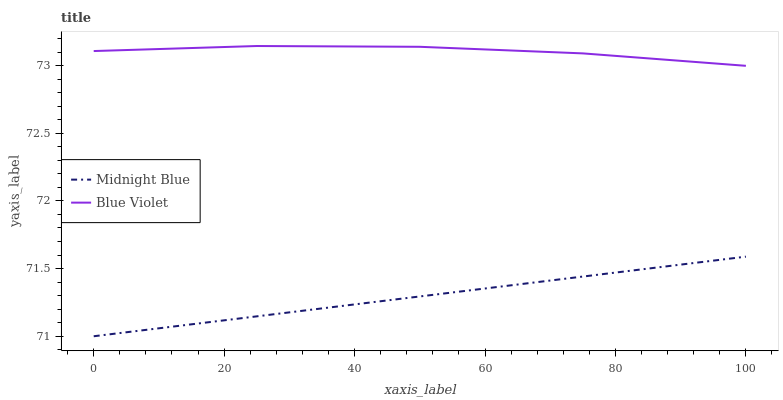Does Midnight Blue have the minimum area under the curve?
Answer yes or no. Yes. Does Blue Violet have the maximum area under the curve?
Answer yes or no. Yes. Does Blue Violet have the minimum area under the curve?
Answer yes or no. No. Is Midnight Blue the smoothest?
Answer yes or no. Yes. Is Blue Violet the roughest?
Answer yes or no. Yes. Is Blue Violet the smoothest?
Answer yes or no. No. Does Blue Violet have the lowest value?
Answer yes or no. No. Is Midnight Blue less than Blue Violet?
Answer yes or no. Yes. Is Blue Violet greater than Midnight Blue?
Answer yes or no. Yes. Does Midnight Blue intersect Blue Violet?
Answer yes or no. No. 